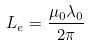<formula> <loc_0><loc_0><loc_500><loc_500>L _ { e } = \frac { \mu _ { 0 } \lambda _ { 0 } } { 2 \pi }</formula> 